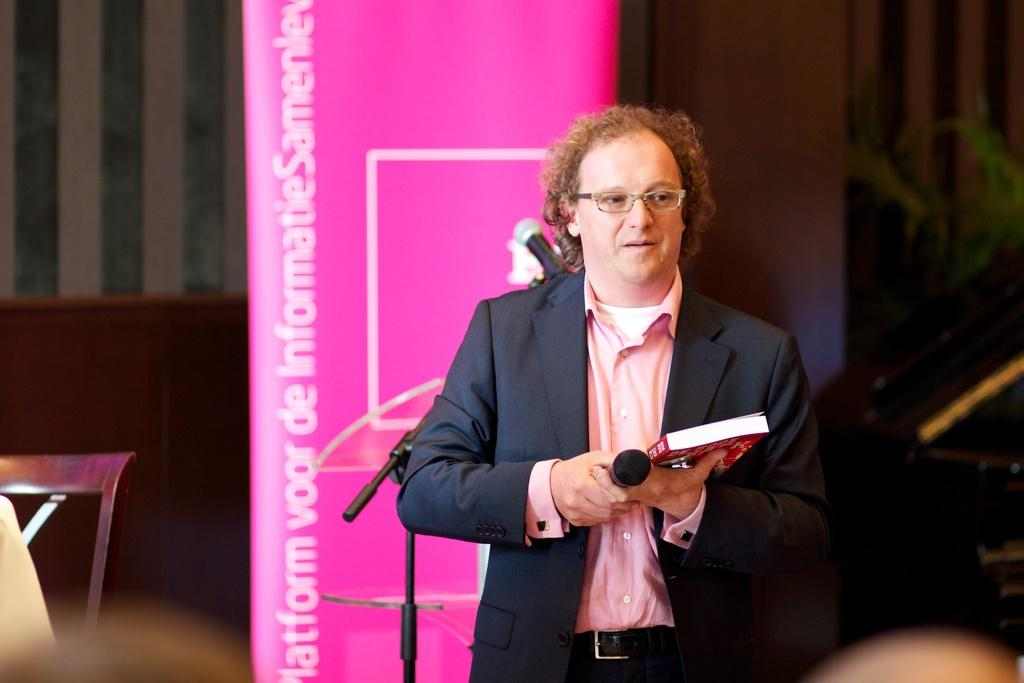What is the man in the image wearing? The man is wearing a suit in the image. What is the man holding in his hands? The man is holding a book and a microphone in the image. What can be seen on the stand in the image? The information about the stand is not provided, so we cannot determine what is on it. What is written on the banner in the image? The information about the banner's content is not provided, so we cannot determine what is written on it. What type of chair is on the left side of the image? There is a wooden chair on the left side of the image. What is visible in the background of the image? There is a wall in the background of the image. How many matches does the man have in his pocket in the image? There is no information about matches in the image, so we cannot determine if the man has any matches. 